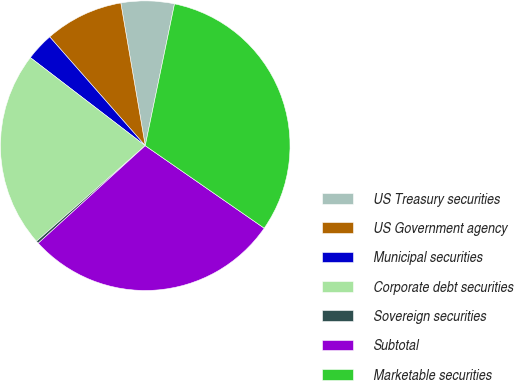Convert chart to OTSL. <chart><loc_0><loc_0><loc_500><loc_500><pie_chart><fcel>US Treasury securities<fcel>US Government agency<fcel>Municipal securities<fcel>Corporate debt securities<fcel>Sovereign securities<fcel>Subtotal<fcel>Marketable securities<nl><fcel>5.94%<fcel>8.77%<fcel>3.12%<fcel>21.89%<fcel>0.29%<fcel>28.58%<fcel>31.41%<nl></chart> 